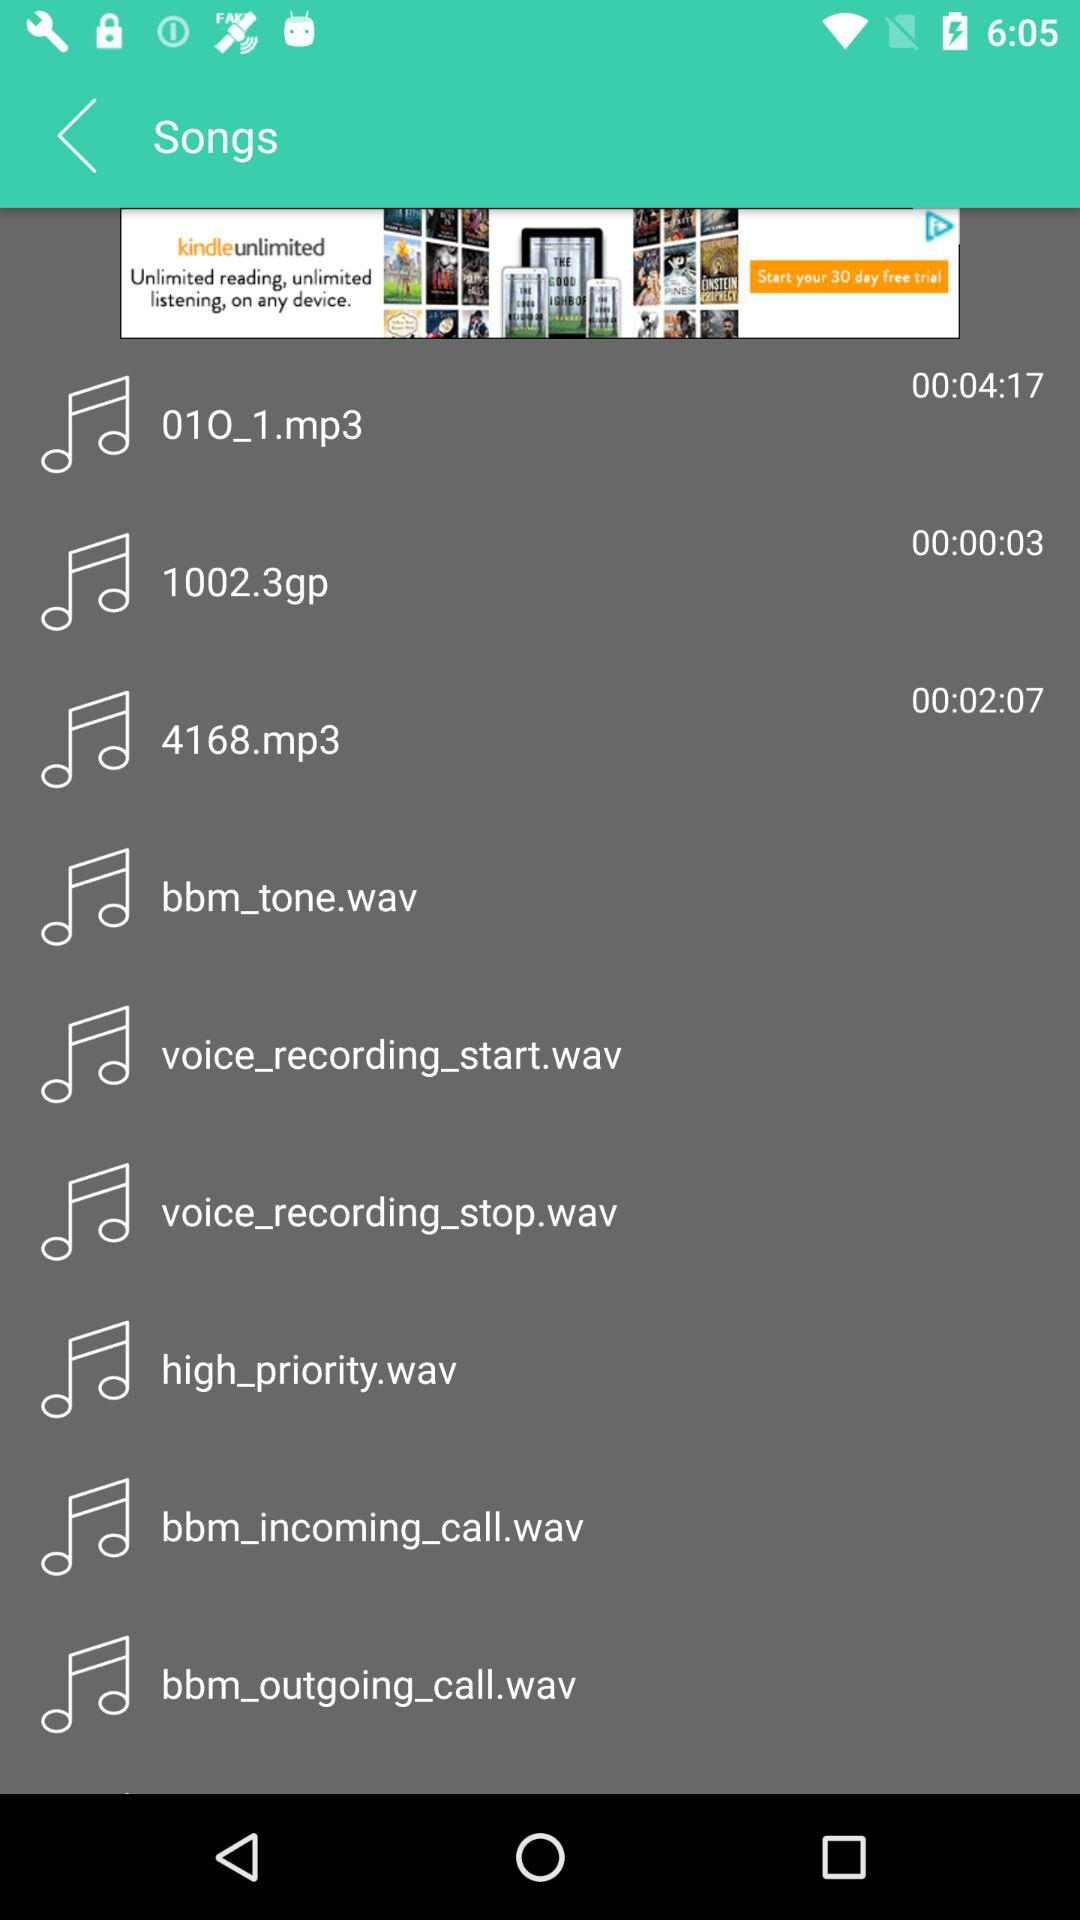Which track has the duration of 2 minutes and 7 seconds? The track is "4168.mp3". 